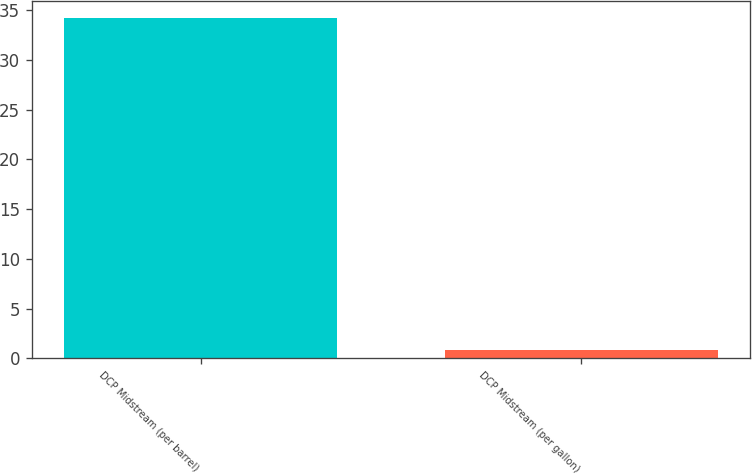Convert chart. <chart><loc_0><loc_0><loc_500><loc_500><bar_chart><fcel>DCP Midstream (per barrel)<fcel>DCP Midstream (per gallon)<nl><fcel>34.24<fcel>0.82<nl></chart> 